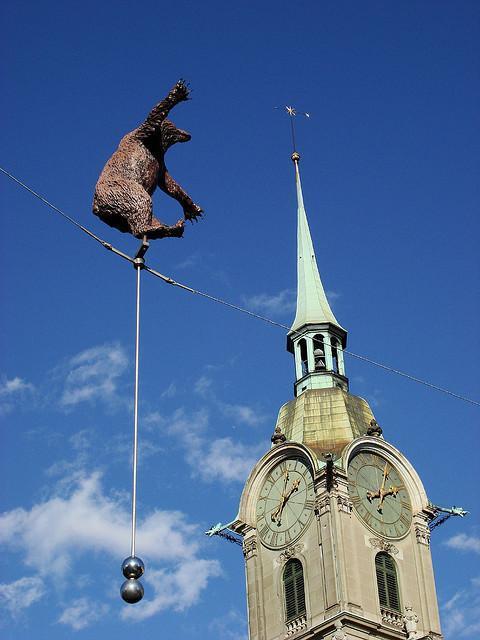In which direction is the bear seen here currently moving?
Select the accurate response from the four choices given to answer the question.
Options: Down, up, forward, none. None. 